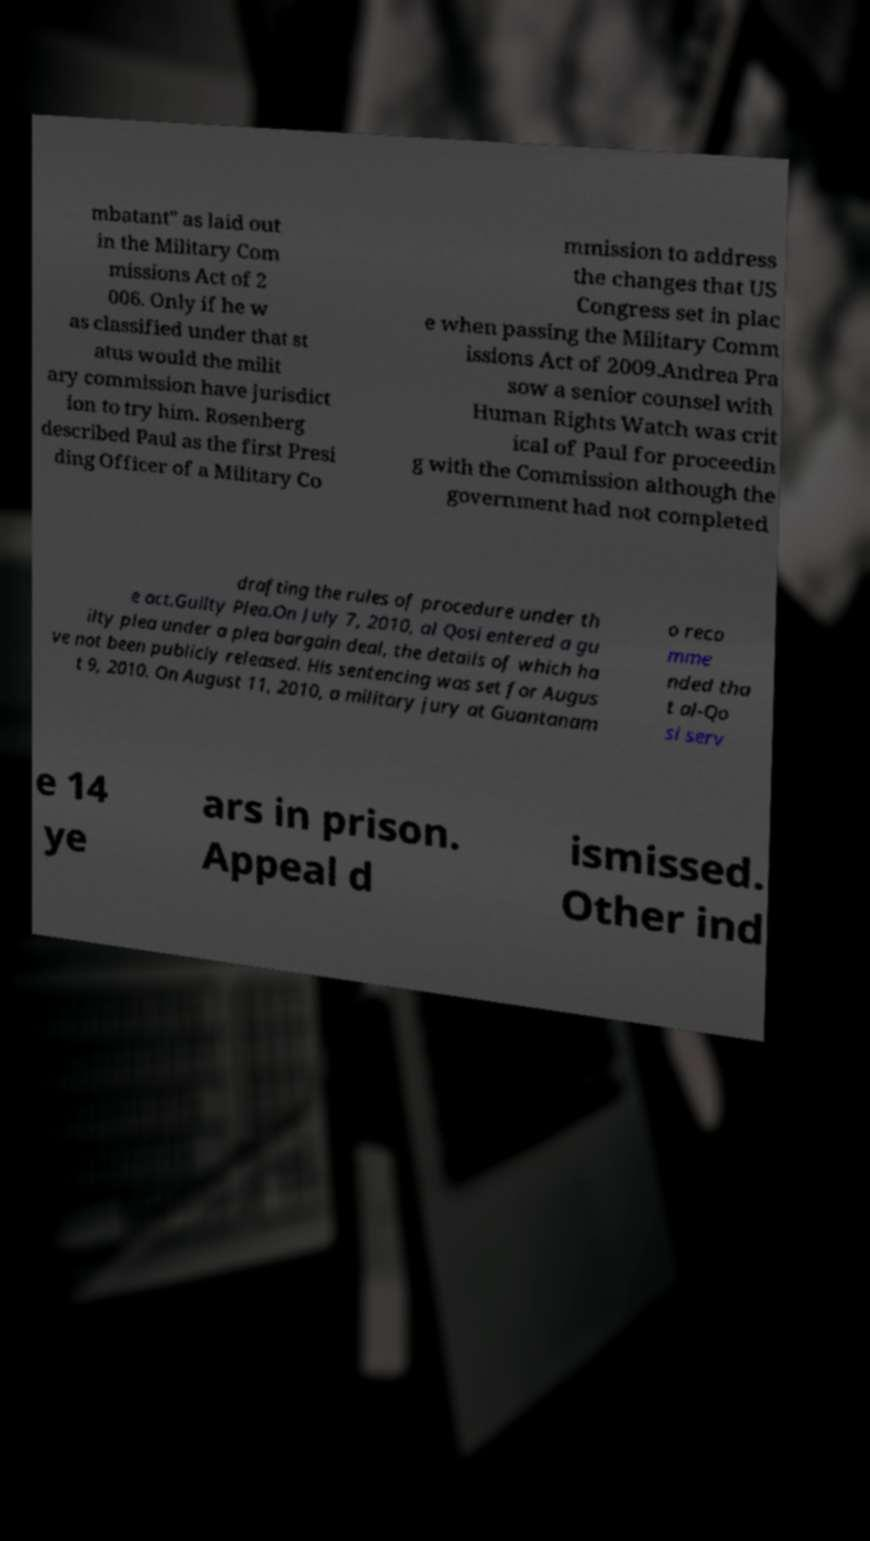Can you read and provide the text displayed in the image?This photo seems to have some interesting text. Can you extract and type it out for me? mbatant" as laid out in the Military Com missions Act of 2 006. Only if he w as classified under that st atus would the milit ary commission have jurisdict ion to try him. Rosenberg described Paul as the first Presi ding Officer of a Military Co mmission to address the changes that US Congress set in plac e when passing the Military Comm issions Act of 2009.Andrea Pra sow a senior counsel with Human Rights Watch was crit ical of Paul for proceedin g with the Commission although the government had not completed drafting the rules of procedure under th e act.Guilty Plea.On July 7, 2010, al Qosi entered a gu ilty plea under a plea bargain deal, the details of which ha ve not been publicly released. His sentencing was set for Augus t 9, 2010. On August 11, 2010, a military jury at Guantanam o reco mme nded tha t al-Qo si serv e 14 ye ars in prison. Appeal d ismissed. Other ind 